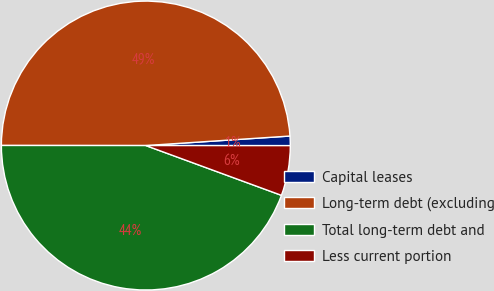Convert chart to OTSL. <chart><loc_0><loc_0><loc_500><loc_500><pie_chart><fcel>Capital leases<fcel>Long-term debt (excluding<fcel>Total long-term debt and<fcel>Less current portion<nl><fcel>1.06%<fcel>48.94%<fcel>44.41%<fcel>5.59%<nl></chart> 